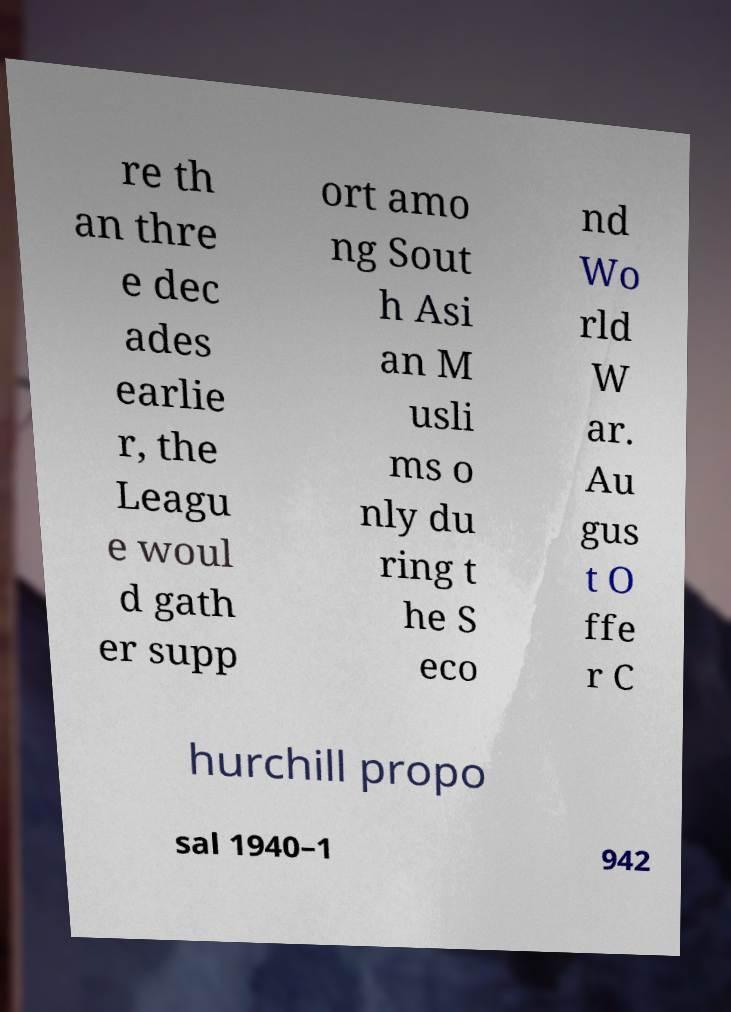What messages or text are displayed in this image? I need them in a readable, typed format. re th an thre e dec ades earlie r, the Leagu e woul d gath er supp ort amo ng Sout h Asi an M usli ms o nly du ring t he S eco nd Wo rld W ar. Au gus t O ffe r C hurchill propo sal 1940–1 942 